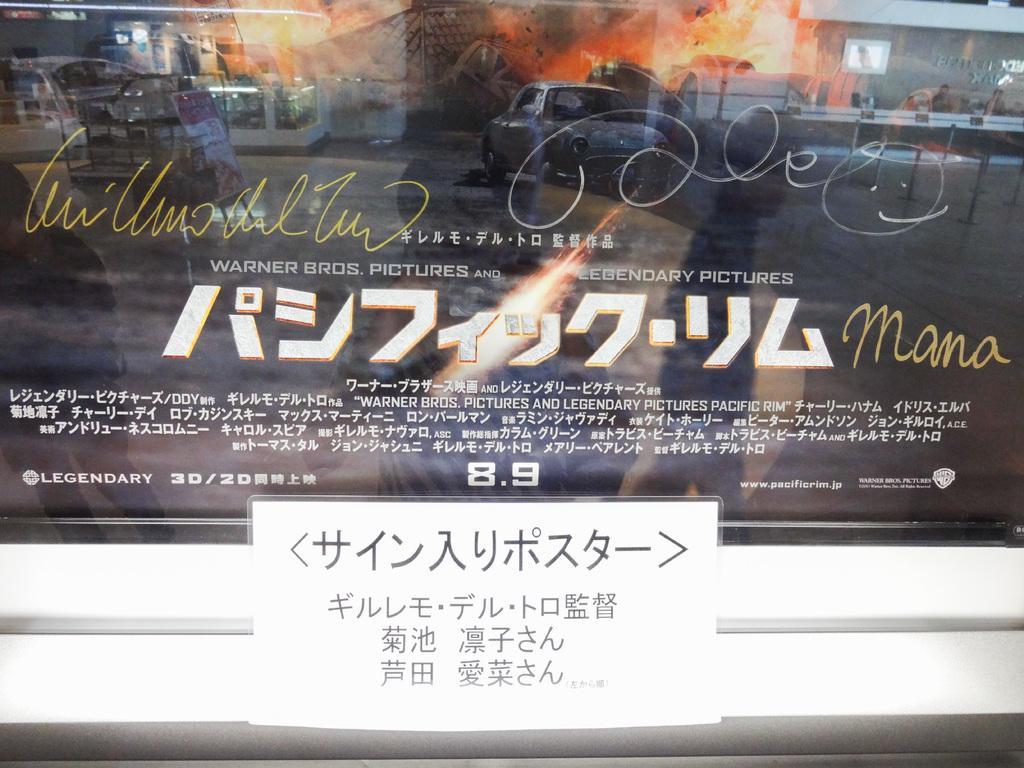In one or two sentences, can you explain what this image depicts? In this picture we can see a poster on the glass. On the bottom we can see sign board. In the reflection we can see cars, buildings and fire. 